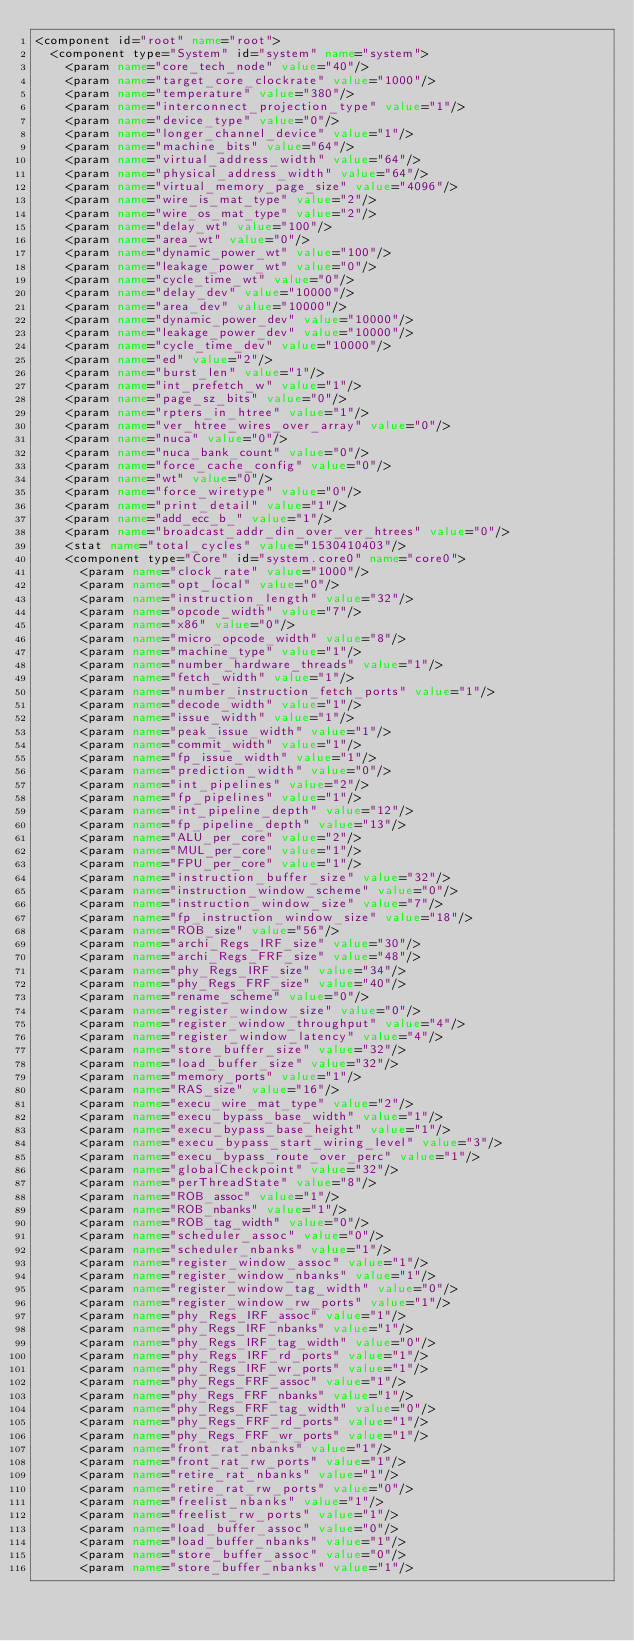Convert code to text. <code><loc_0><loc_0><loc_500><loc_500><_XML_><component id="root" name="root">
  <component type="System" id="system" name="system">
    <param name="core_tech_node" value="40"/>
    <param name="target_core_clockrate" value="1000"/>
    <param name="temperature" value="380"/>
    <param name="interconnect_projection_type" value="1"/>
    <param name="device_type" value="0"/>
    <param name="longer_channel_device" value="1"/>
    <param name="machine_bits" value="64"/>
    <param name="virtual_address_width" value="64"/>
    <param name="physical_address_width" value="64"/>
    <param name="virtual_memory_page_size" value="4096"/>
    <param name="wire_is_mat_type" value="2"/>
    <param name="wire_os_mat_type" value="2"/>
    <param name="delay_wt" value="100"/>
    <param name="area_wt" value="0"/>
    <param name="dynamic_power_wt" value="100"/>
    <param name="leakage_power_wt" value="0"/>
    <param name="cycle_time_wt" value="0"/>
    <param name="delay_dev" value="10000"/>
    <param name="area_dev" value="10000"/>
    <param name="dynamic_power_dev" value="10000"/>
    <param name="leakage_power_dev" value="10000"/>
    <param name="cycle_time_dev" value="10000"/>
    <param name="ed" value="2"/>
    <param name="burst_len" value="1"/>
    <param name="int_prefetch_w" value="1"/>
    <param name="page_sz_bits" value="0"/>
    <param name="rpters_in_htree" value="1"/>
    <param name="ver_htree_wires_over_array" value="0"/>
    <param name="nuca" value="0"/>
    <param name="nuca_bank_count" value="0"/>
    <param name="force_cache_config" value="0"/>
    <param name="wt" value="0"/>
    <param name="force_wiretype" value="0"/>
    <param name="print_detail" value="1"/>
    <param name="add_ecc_b_" value="1"/>
    <param name="broadcast_addr_din_over_ver_htrees" value="0"/>
    <stat name="total_cycles" value="1530410403"/>
    <component type="Core" id="system.core0" name="core0">
      <param name="clock_rate" value="1000"/>
      <param name="opt_local" value="0"/>
      <param name="instruction_length" value="32"/>
      <param name="opcode_width" value="7"/>
      <param name="x86" value="0"/>
      <param name="micro_opcode_width" value="8"/>
      <param name="machine_type" value="1"/>
      <param name="number_hardware_threads" value="1"/>
      <param name="fetch_width" value="1"/>
      <param name="number_instruction_fetch_ports" value="1"/>
      <param name="decode_width" value="1"/>
      <param name="issue_width" value="1"/>
      <param name="peak_issue_width" value="1"/>
      <param name="commit_width" value="1"/>
      <param name="fp_issue_width" value="1"/>
      <param name="prediction_width" value="0"/>
      <param name="int_pipelines" value="2"/>
      <param name="fp_pipelines" value="1"/>
      <param name="int_pipeline_depth" value="12"/>
      <param name="fp_pipeline_depth" value="13"/>
      <param name="ALU_per_core" value="2"/>
      <param name="MUL_per_core" value="1"/>
      <param name="FPU_per_core" value="1"/>
      <param name="instruction_buffer_size" value="32"/>
      <param name="instruction_window_scheme" value="0"/>
      <param name="instruction_window_size" value="7"/>
      <param name="fp_instruction_window_size" value="18"/>
      <param name="ROB_size" value="56"/>
      <param name="archi_Regs_IRF_size" value="30"/>
      <param name="archi_Regs_FRF_size" value="48"/>
      <param name="phy_Regs_IRF_size" value="34"/>
      <param name="phy_Regs_FRF_size" value="40"/>
      <param name="rename_scheme" value="0"/>
      <param name="register_window_size" value="0"/>
      <param name="register_window_throughput" value="4"/>
      <param name="register_window_latency" value="4"/>
      <param name="store_buffer_size" value="32"/>
      <param name="load_buffer_size" value="32"/>
      <param name="memory_ports" value="1"/>
      <param name="RAS_size" value="16"/>
      <param name="execu_wire_mat_type" value="2"/>
      <param name="execu_bypass_base_width" value="1"/>
      <param name="execu_bypass_base_height" value="1"/>
      <param name="execu_bypass_start_wiring_level" value="3"/>
      <param name="execu_bypass_route_over_perc" value="1"/>
      <param name="globalCheckpoint" value="32"/>
      <param name="perThreadState" value="8"/>
      <param name="ROB_assoc" value="1"/>
      <param name="ROB_nbanks" value="1"/>
      <param name="ROB_tag_width" value="0"/>
      <param name="scheduler_assoc" value="0"/>
      <param name="scheduler_nbanks" value="1"/>
      <param name="register_window_assoc" value="1"/>
      <param name="register_window_nbanks" value="1"/>
      <param name="register_window_tag_width" value="0"/>
      <param name="register_window_rw_ports" value="1"/>
      <param name="phy_Regs_IRF_assoc" value="1"/>
      <param name="phy_Regs_IRF_nbanks" value="1"/>
      <param name="phy_Regs_IRF_tag_width" value="0"/>
      <param name="phy_Regs_IRF_rd_ports" value="1"/>
      <param name="phy_Regs_IRF_wr_ports" value="1"/>
      <param name="phy_Regs_FRF_assoc" value="1"/>
      <param name="phy_Regs_FRF_nbanks" value="1"/>
      <param name="phy_Regs_FRF_tag_width" value="0"/>
      <param name="phy_Regs_FRF_rd_ports" value="1"/>
      <param name="phy_Regs_FRF_wr_ports" value="1"/>
      <param name="front_rat_nbanks" value="1"/>
      <param name="front_rat_rw_ports" value="1"/>
      <param name="retire_rat_nbanks" value="1"/>
      <param name="retire_rat_rw_ports" value="0"/>
      <param name="freelist_nbanks" value="1"/>
      <param name="freelist_rw_ports" value="1"/>
      <param name="load_buffer_assoc" value="0"/>
      <param name="load_buffer_nbanks" value="1"/>
      <param name="store_buffer_assoc" value="0"/>
      <param name="store_buffer_nbanks" value="1"/></code> 